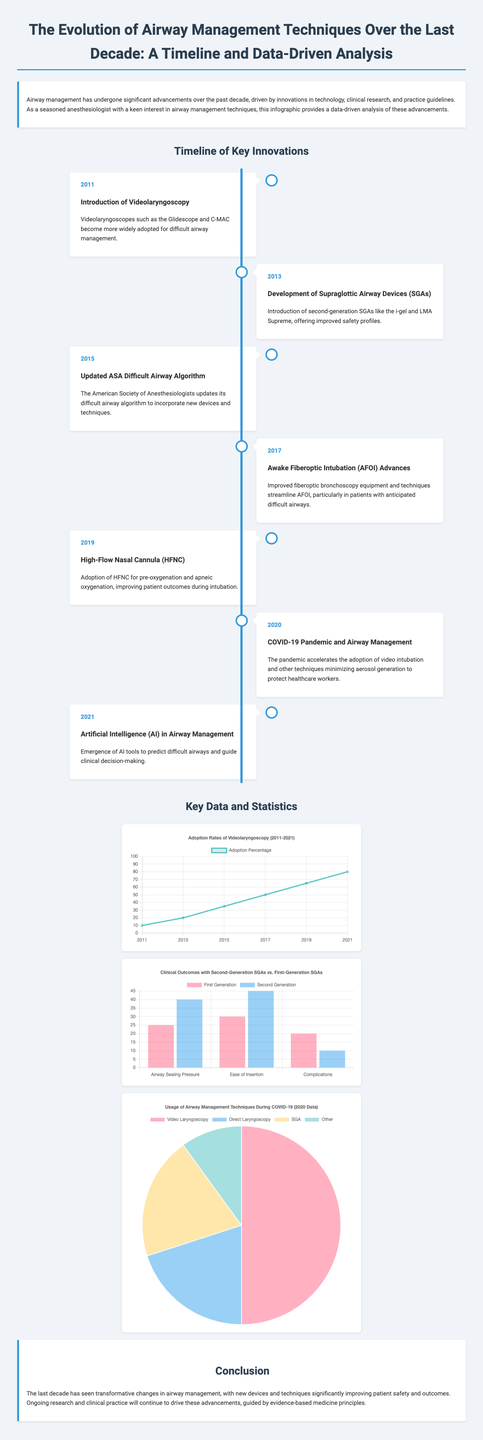What year was videolaryngoscopy introduced? The infographic states that videolaryngoscopy was introduced in 2011.
Answer: 2011 What significant airway device was developed in 2013? The document mentions the development of second-generation supraglottic airway devices in 2013.
Answer: Supraglottic Airway Devices What was updated by the American Society of Anesthesiologists in 2015? The document refers to the update of the difficult airway algorithm by the American Society of Anesthesiologists.
Answer: Difficult Airway Algorithm What adoption percentage did videolaryngoscopy reach in 2021? According to the chart, the adoption percentage of videolaryngoscopy in 2021 was 80%.
Answer: 80% Which airway management technique saw increased usage during the COVID-19 pandemic? The document indicates that video intubation was accelerated due to the COVID-19 pandemic.
Answer: Video Intubation What percentage of complications are associated with first-generation SGAs? The chart shows that complications for first-generation SGAs amount to 20%.
Answer: 20% How many innovations are highlighted in the timeline? The timeline outlines seven key innovations in airway management techniques.
Answer: Seven What type of chart is used to display the clinical outcomes with SGAs? The infographic uses a bar chart to display the clinical outcomes with first and second-generation SGAs.
Answer: Bar Chart 